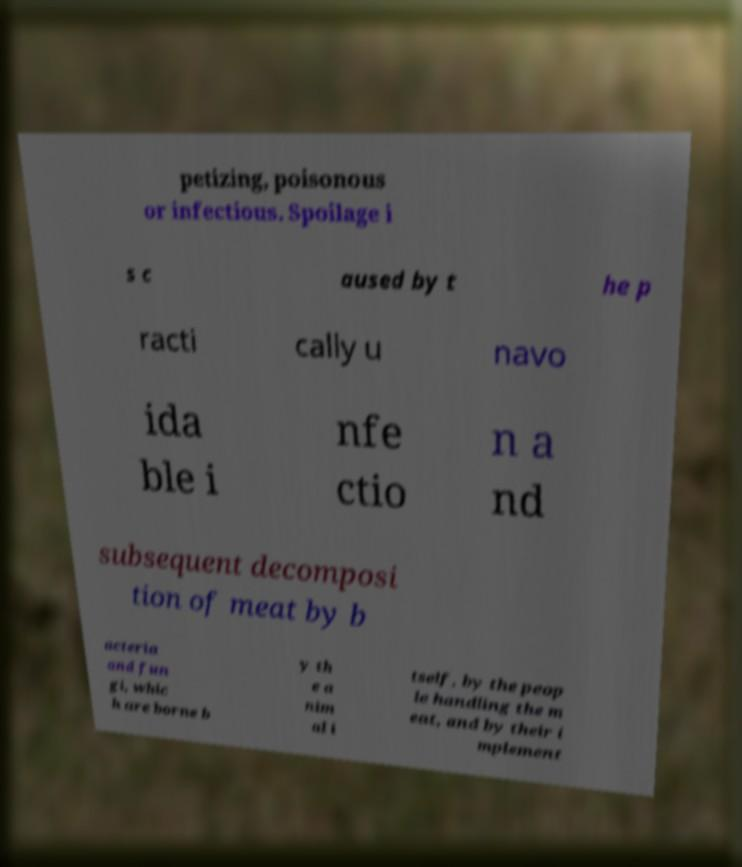For documentation purposes, I need the text within this image transcribed. Could you provide that? petizing, poisonous or infectious. Spoilage i s c aused by t he p racti cally u navo ida ble i nfe ctio n a nd subsequent decomposi tion of meat by b acteria and fun gi, whic h are borne b y th e a nim al i tself, by the peop le handling the m eat, and by their i mplement 